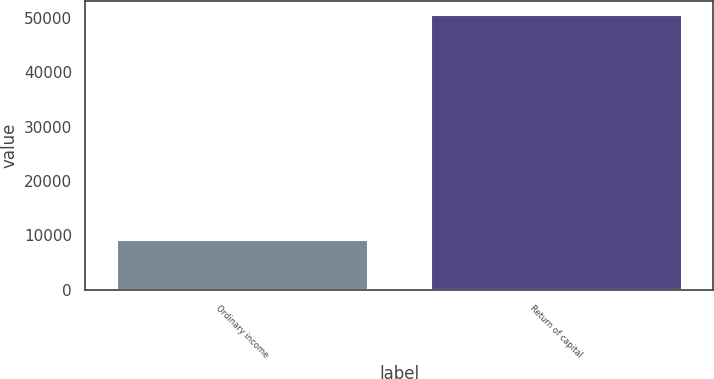Convert chart to OTSL. <chart><loc_0><loc_0><loc_500><loc_500><bar_chart><fcel>Ordinary income<fcel>Return of capital<nl><fcel>9079<fcel>50549<nl></chart> 